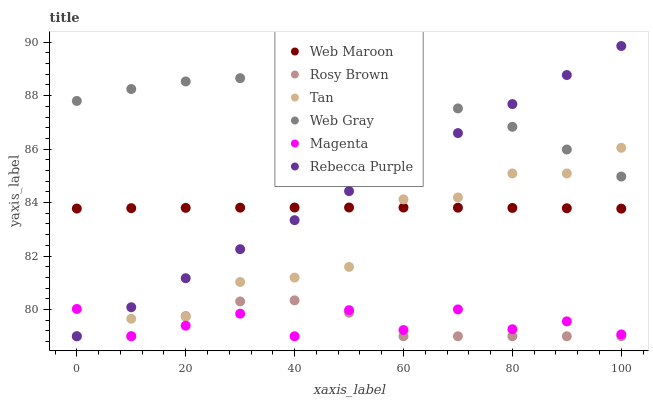Does Rosy Brown have the minimum area under the curve?
Answer yes or no. Yes. Does Web Gray have the maximum area under the curve?
Answer yes or no. Yes. Does Web Maroon have the minimum area under the curve?
Answer yes or no. No. Does Web Maroon have the maximum area under the curve?
Answer yes or no. No. Is Rebecca Purple the smoothest?
Answer yes or no. Yes. Is Magenta the roughest?
Answer yes or no. Yes. Is Rosy Brown the smoothest?
Answer yes or no. No. Is Rosy Brown the roughest?
Answer yes or no. No. Does Rosy Brown have the lowest value?
Answer yes or no. Yes. Does Web Maroon have the lowest value?
Answer yes or no. No. Does Rebecca Purple have the highest value?
Answer yes or no. Yes. Does Rosy Brown have the highest value?
Answer yes or no. No. Is Web Maroon less than Web Gray?
Answer yes or no. Yes. Is Web Gray greater than Rosy Brown?
Answer yes or no. Yes. Does Tan intersect Web Maroon?
Answer yes or no. Yes. Is Tan less than Web Maroon?
Answer yes or no. No. Is Tan greater than Web Maroon?
Answer yes or no. No. Does Web Maroon intersect Web Gray?
Answer yes or no. No. 